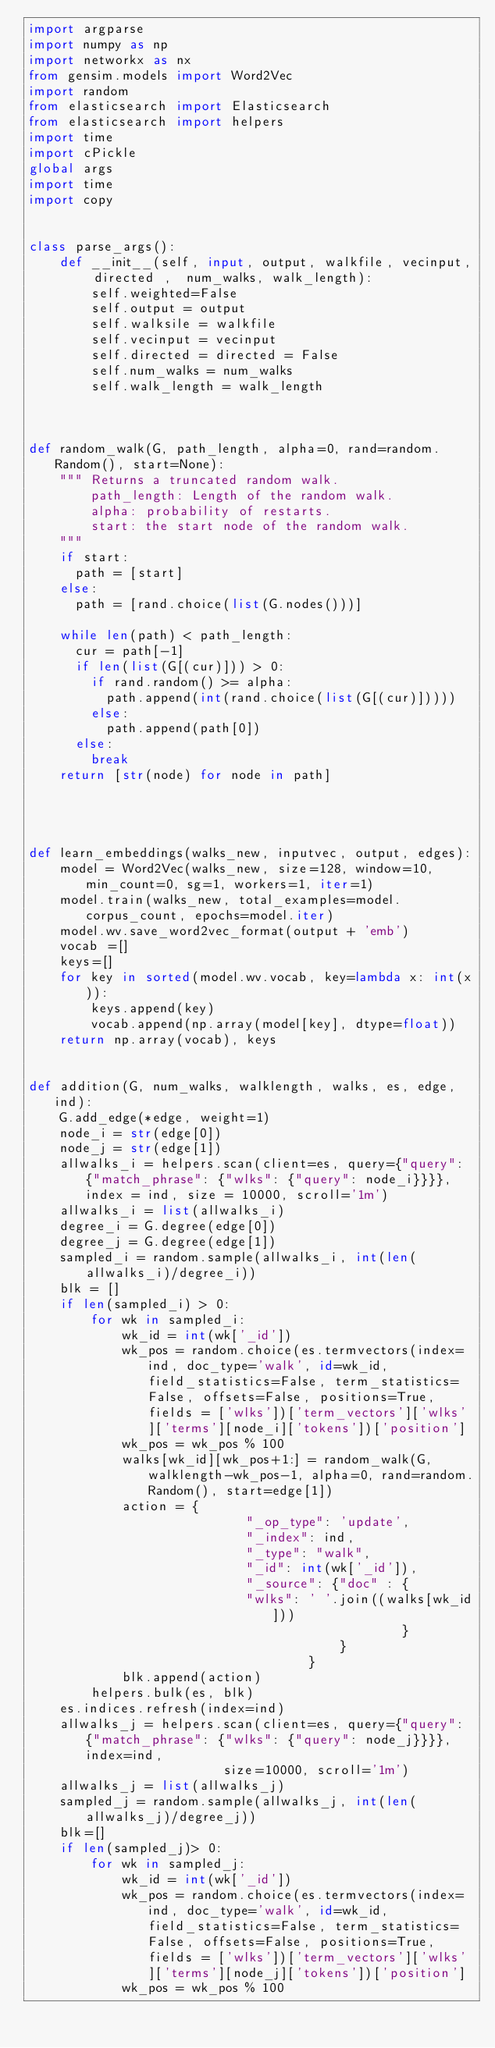Convert code to text. <code><loc_0><loc_0><loc_500><loc_500><_Python_>import argparse
import numpy as np
import networkx as nx
from gensim.models import Word2Vec
import random
from elasticsearch import Elasticsearch
from elasticsearch import helpers
import time
import cPickle
global args
import time
import copy


class parse_args():
	def __init__(self, input, output, walkfile, vecinput, directed ,  num_walks, walk_length):
		self.weighted=False
		self.output = output
		self.walksile = walkfile
		self.vecinput = vecinput
		self.directed = directed = False
		self.num_walks = num_walks
		self.walk_length = walk_length



def random_walk(G, path_length, alpha=0, rand=random.Random(), start=None):
    """ Returns a truncated random walk.
        path_length: Length of the random walk.
        alpha: probability of restarts.
        start: the start node of the random walk.
    """
    if start:
      path = [start]
    else:
      path = [rand.choice(list(G.nodes()))]

    while len(path) < path_length:
      cur = path[-1]
      if len(list(G[(cur)])) > 0:
        if rand.random() >= alpha:
          path.append(int(rand.choice(list(G[(cur)]))))
        else:
          path.append(path[0])
      else:
        break
    return [str(node) for node in path]




def learn_embeddings(walks_new, inputvec, output, edges):
	model = Word2Vec(walks_new, size=128, window=10, min_count=0, sg=1, workers=1, iter=1)	
	model.train(walks_new, total_examples=model.corpus_count, epochs=model.iter)
	model.wv.save_word2vec_format(output + 'emb')
	vocab =[]
	keys=[]
	for key in sorted(model.wv.vocab, key=lambda x: int(x)):
		keys.append(key)
		vocab.append(np.array(model[key], dtype=float))
	return np.array(vocab), keys
	

def addition(G, num_walks, walklength, walks, es, edge, ind):
	G.add_edge(*edge, weight=1)
	node_i = str(edge[0])
	node_j = str(edge[1])
	allwalks_i = helpers.scan(client=es, query={"query": {"match_phrase": {"wlks": {"query": node_i}}}}, index = ind, size = 10000, scroll='1m')
	allwalks_i = list(allwalks_i)
	degree_i = G.degree(edge[0])
	degree_j = G.degree(edge[1])
	sampled_i = random.sample(allwalks_i, int(len(allwalks_i)/degree_i))
	blk = []
	if len(sampled_i) > 0:
		for wk in sampled_i:
			wk_id = int(wk['_id'])
			wk_pos = random.choice(es.termvectors(index=ind, doc_type='walk', id=wk_id, field_statistics=False, term_statistics=False, offsets=False, positions=True, fields = ['wlks'])['term_vectors']['wlks']['terms'][node_i]['tokens'])['position']
			wk_pos = wk_pos % 100
			walks[wk_id][wk_pos+1:] = random_walk(G, walklength-wk_pos-1, alpha=0, rand=random.Random(), start=edge[1])
			action = {
							"_op_type": 'update',
						 	"_index": ind,
							"_type": "walk",
							"_id": int(wk['_id']),
							"_source": {"doc" : {
							"wlks": ' '.join((walks[wk_id]))
												}
										}
		 							}
	 		blk.append(action)
		helpers.bulk(es, blk)
	es.indices.refresh(index=ind)
	allwalks_j = helpers.scan(client=es, query={"query": {"match_phrase": {"wlks": {"query": node_j}}}}, index=ind,
						 size=10000, scroll='1m')
	allwalks_j = list(allwalks_j)
	sampled_j = random.sample(allwalks_j, int(len(allwalks_j)/degree_j))
	blk=[]
	if len(sampled_j)> 0:
		for wk in sampled_j:
			wk_id = int(wk['_id'])
			wk_pos = random.choice(es.termvectors(index=ind, doc_type='walk', id=wk_id, field_statistics=False, term_statistics=False, offsets=False, positions=True, fields = ['wlks'])['term_vectors']['wlks']['terms'][node_j]['tokens'])['position']
			wk_pos = wk_pos % 100</code> 